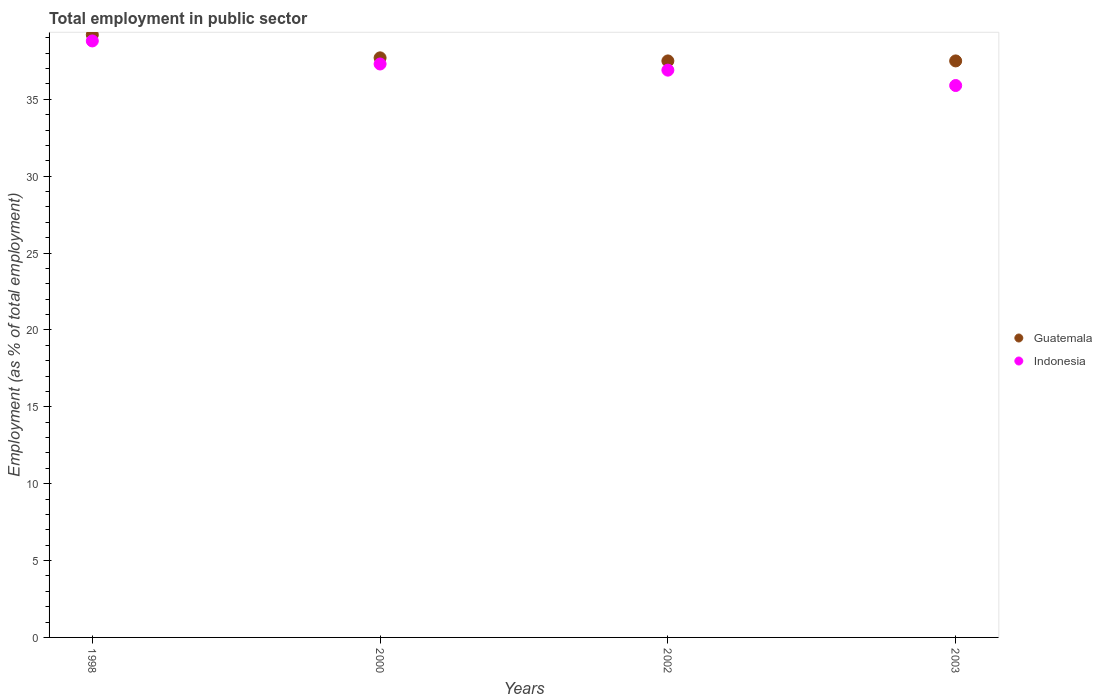How many different coloured dotlines are there?
Your answer should be compact. 2. What is the employment in public sector in Indonesia in 2003?
Your answer should be very brief. 35.9. Across all years, what is the maximum employment in public sector in Indonesia?
Offer a terse response. 38.8. Across all years, what is the minimum employment in public sector in Guatemala?
Offer a terse response. 37.5. In which year was the employment in public sector in Guatemala minimum?
Provide a short and direct response. 2002. What is the total employment in public sector in Guatemala in the graph?
Your answer should be very brief. 151.9. What is the difference between the employment in public sector in Indonesia in 2000 and that in 2003?
Provide a succinct answer. 1.4. What is the difference between the employment in public sector in Guatemala in 2002 and the employment in public sector in Indonesia in 2000?
Keep it short and to the point. 0.2. What is the average employment in public sector in Guatemala per year?
Keep it short and to the point. 37.98. In the year 2003, what is the difference between the employment in public sector in Indonesia and employment in public sector in Guatemala?
Your answer should be compact. -1.6. In how many years, is the employment in public sector in Indonesia greater than 27 %?
Your response must be concise. 4. What is the ratio of the employment in public sector in Indonesia in 2000 to that in 2002?
Keep it short and to the point. 1.01. What is the difference between the highest and the lowest employment in public sector in Indonesia?
Your answer should be compact. 2.9. In how many years, is the employment in public sector in Indonesia greater than the average employment in public sector in Indonesia taken over all years?
Your response must be concise. 2. Does the employment in public sector in Indonesia monotonically increase over the years?
Give a very brief answer. No. How many years are there in the graph?
Provide a succinct answer. 4. Are the values on the major ticks of Y-axis written in scientific E-notation?
Keep it short and to the point. No. Does the graph contain any zero values?
Offer a terse response. No. Does the graph contain grids?
Make the answer very short. No. Where does the legend appear in the graph?
Keep it short and to the point. Center right. What is the title of the graph?
Your answer should be compact. Total employment in public sector. Does "Ecuador" appear as one of the legend labels in the graph?
Offer a terse response. No. What is the label or title of the Y-axis?
Your answer should be very brief. Employment (as % of total employment). What is the Employment (as % of total employment) in Guatemala in 1998?
Your answer should be compact. 39.2. What is the Employment (as % of total employment) of Indonesia in 1998?
Offer a terse response. 38.8. What is the Employment (as % of total employment) in Guatemala in 2000?
Your answer should be compact. 37.7. What is the Employment (as % of total employment) of Indonesia in 2000?
Offer a very short reply. 37.3. What is the Employment (as % of total employment) in Guatemala in 2002?
Offer a terse response. 37.5. What is the Employment (as % of total employment) of Indonesia in 2002?
Your response must be concise. 36.9. What is the Employment (as % of total employment) in Guatemala in 2003?
Your answer should be very brief. 37.5. What is the Employment (as % of total employment) in Indonesia in 2003?
Provide a short and direct response. 35.9. Across all years, what is the maximum Employment (as % of total employment) in Guatemala?
Keep it short and to the point. 39.2. Across all years, what is the maximum Employment (as % of total employment) of Indonesia?
Your response must be concise. 38.8. Across all years, what is the minimum Employment (as % of total employment) of Guatemala?
Give a very brief answer. 37.5. Across all years, what is the minimum Employment (as % of total employment) of Indonesia?
Provide a short and direct response. 35.9. What is the total Employment (as % of total employment) of Guatemala in the graph?
Provide a short and direct response. 151.9. What is the total Employment (as % of total employment) in Indonesia in the graph?
Give a very brief answer. 148.9. What is the difference between the Employment (as % of total employment) in Guatemala in 1998 and that in 2000?
Your response must be concise. 1.5. What is the difference between the Employment (as % of total employment) in Indonesia in 1998 and that in 2002?
Provide a succinct answer. 1.9. What is the difference between the Employment (as % of total employment) of Guatemala in 1998 and that in 2003?
Keep it short and to the point. 1.7. What is the difference between the Employment (as % of total employment) of Indonesia in 2000 and that in 2002?
Make the answer very short. 0.4. What is the difference between the Employment (as % of total employment) of Guatemala in 2000 and that in 2003?
Your answer should be compact. 0.2. What is the difference between the Employment (as % of total employment) of Guatemala in 2002 and that in 2003?
Make the answer very short. 0. What is the difference between the Employment (as % of total employment) of Indonesia in 2002 and that in 2003?
Keep it short and to the point. 1. What is the difference between the Employment (as % of total employment) of Guatemala in 1998 and the Employment (as % of total employment) of Indonesia in 2002?
Provide a short and direct response. 2.3. What is the difference between the Employment (as % of total employment) in Guatemala in 2000 and the Employment (as % of total employment) in Indonesia in 2002?
Provide a short and direct response. 0.8. What is the difference between the Employment (as % of total employment) in Guatemala in 2000 and the Employment (as % of total employment) in Indonesia in 2003?
Your response must be concise. 1.8. What is the difference between the Employment (as % of total employment) of Guatemala in 2002 and the Employment (as % of total employment) of Indonesia in 2003?
Provide a succinct answer. 1.6. What is the average Employment (as % of total employment) of Guatemala per year?
Ensure brevity in your answer.  37.98. What is the average Employment (as % of total employment) in Indonesia per year?
Provide a short and direct response. 37.23. In the year 2002, what is the difference between the Employment (as % of total employment) of Guatemala and Employment (as % of total employment) of Indonesia?
Offer a terse response. 0.6. In the year 2003, what is the difference between the Employment (as % of total employment) in Guatemala and Employment (as % of total employment) in Indonesia?
Offer a very short reply. 1.6. What is the ratio of the Employment (as % of total employment) in Guatemala in 1998 to that in 2000?
Make the answer very short. 1.04. What is the ratio of the Employment (as % of total employment) in Indonesia in 1998 to that in 2000?
Give a very brief answer. 1.04. What is the ratio of the Employment (as % of total employment) in Guatemala in 1998 to that in 2002?
Offer a very short reply. 1.05. What is the ratio of the Employment (as % of total employment) in Indonesia in 1998 to that in 2002?
Keep it short and to the point. 1.05. What is the ratio of the Employment (as % of total employment) of Guatemala in 1998 to that in 2003?
Your answer should be compact. 1.05. What is the ratio of the Employment (as % of total employment) of Indonesia in 1998 to that in 2003?
Your response must be concise. 1.08. What is the ratio of the Employment (as % of total employment) in Indonesia in 2000 to that in 2002?
Provide a succinct answer. 1.01. What is the ratio of the Employment (as % of total employment) of Indonesia in 2000 to that in 2003?
Your response must be concise. 1.04. What is the ratio of the Employment (as % of total employment) in Guatemala in 2002 to that in 2003?
Make the answer very short. 1. What is the ratio of the Employment (as % of total employment) in Indonesia in 2002 to that in 2003?
Make the answer very short. 1.03. What is the difference between the highest and the second highest Employment (as % of total employment) in Guatemala?
Give a very brief answer. 1.5. What is the difference between the highest and the second highest Employment (as % of total employment) in Indonesia?
Provide a short and direct response. 1.5. What is the difference between the highest and the lowest Employment (as % of total employment) of Guatemala?
Make the answer very short. 1.7. 